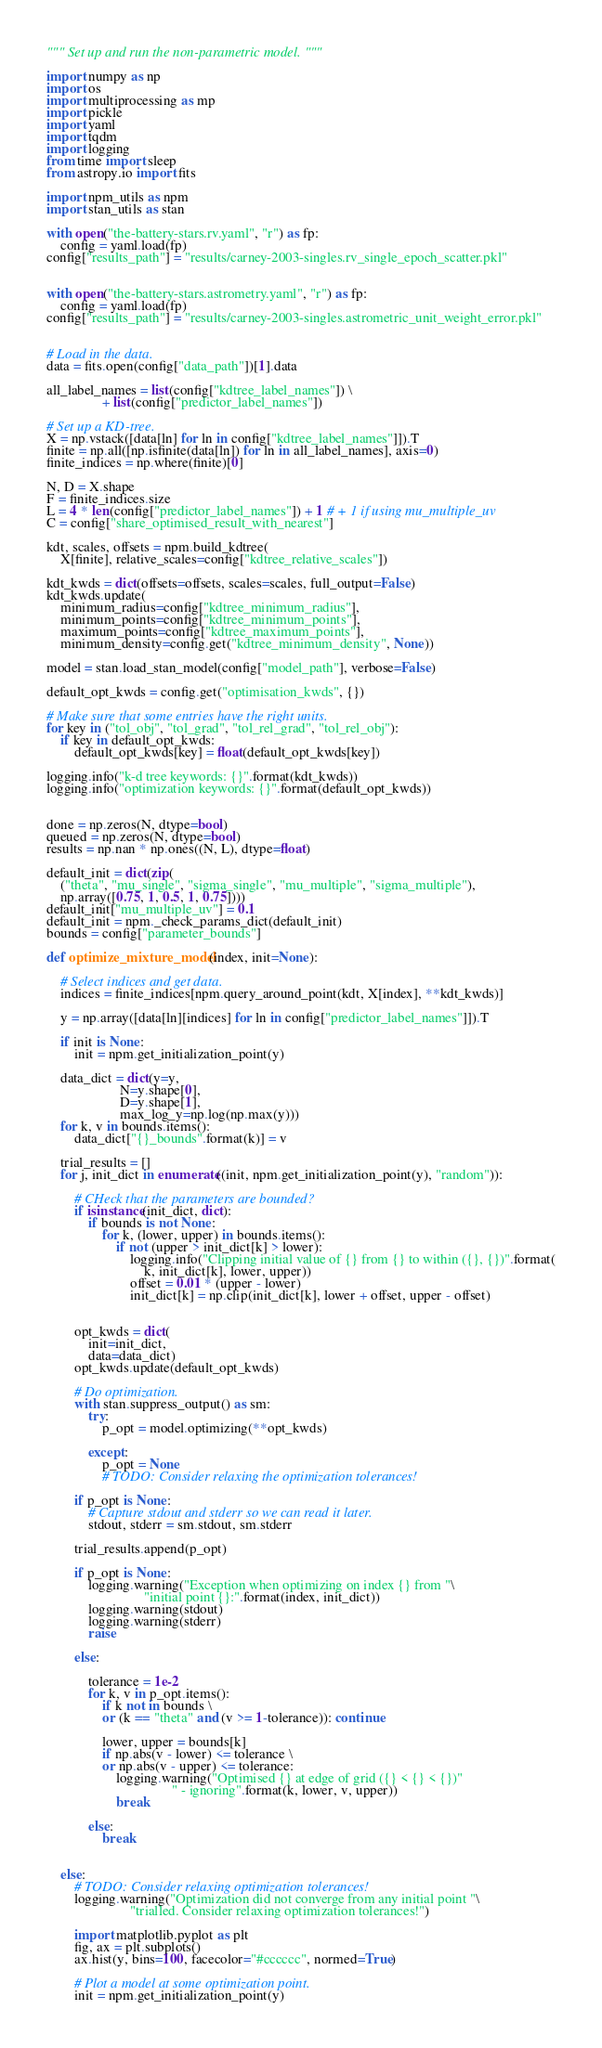<code> <loc_0><loc_0><loc_500><loc_500><_Python_>
""" Set up and run the non-parametric model. """

import numpy as np
import os
import multiprocessing as mp
import pickle
import yaml
import tqdm
import logging
from time import sleep
from astropy.io import fits

import npm_utils as npm
import stan_utils as stan

with open("the-battery-stars.rv.yaml", "r") as fp:
    config = yaml.load(fp)
config["results_path"] = "results/carney-2003-singles.rv_single_epoch_scatter.pkl"


with open("the-battery-stars.astrometry.yaml", "r") as fp:
    config = yaml.load(fp)
config["results_path"] = "results/carney-2003-singles.astrometric_unit_weight_error.pkl"


# Load in the data.
data = fits.open(config["data_path"])[1].data

all_label_names = list(config["kdtree_label_names"]) \
                + list(config["predictor_label_names"])

# Set up a KD-tree.
X = np.vstack([data[ln] for ln in config["kdtree_label_names"]]).T
finite = np.all([np.isfinite(data[ln]) for ln in all_label_names], axis=0)
finite_indices = np.where(finite)[0]

N, D = X.shape
F = finite_indices.size
L = 4 * len(config["predictor_label_names"]) + 1 # + 1 if using mu_multiple_uv
C = config["share_optimised_result_with_nearest"]

kdt, scales, offsets = npm.build_kdtree(
    X[finite], relative_scales=config["kdtree_relative_scales"])

kdt_kwds = dict(offsets=offsets, scales=scales, full_output=False)
kdt_kwds.update(
    minimum_radius=config["kdtree_minimum_radius"],
    minimum_points=config["kdtree_minimum_points"],
    maximum_points=config["kdtree_maximum_points"],
    minimum_density=config.get("kdtree_minimum_density", None))

model = stan.load_stan_model(config["model_path"], verbose=False)

default_opt_kwds = config.get("optimisation_kwds", {})

# Make sure that some entries have the right units.
for key in ("tol_obj", "tol_grad", "tol_rel_grad", "tol_rel_obj"):
    if key in default_opt_kwds:
        default_opt_kwds[key] = float(default_opt_kwds[key])

logging.info("k-d tree keywords: {}".format(kdt_kwds))
logging.info("optimization keywords: {}".format(default_opt_kwds))


done = np.zeros(N, dtype=bool)
queued = np.zeros(N, dtype=bool)
results = np.nan * np.ones((N, L), dtype=float)

default_init = dict(zip(
    ("theta", "mu_single", "sigma_single", "mu_multiple", "sigma_multiple"),
    np.array([0.75, 1, 0.5, 1, 0.75])))
default_init["mu_multiple_uv"] = 0.1
default_init = npm._check_params_dict(default_init)
bounds = config["parameter_bounds"]

def optimize_mixture_model(index, init=None):

    # Select indices and get data.
    indices = finite_indices[npm.query_around_point(kdt, X[index], **kdt_kwds)]

    y = np.array([data[ln][indices] for ln in config["predictor_label_names"]]).T

    if init is None:
        init = npm.get_initialization_point(y)

    data_dict = dict(y=y, 
                     N=y.shape[0], 
                     D=y.shape[1],
                     max_log_y=np.log(np.max(y)))
    for k, v in bounds.items():
        data_dict["{}_bounds".format(k)] = v
    
    trial_results = []
    for j, init_dict in enumerate((init, npm.get_initialization_point(y), "random")):

        # CHeck that the parameters are bounded?
        if isinstance(init_dict, dict):
            if bounds is not None:
                for k, (lower, upper) in bounds.items():
                    if not (upper > init_dict[k] > lower):
                        logging.info("Clipping initial value of {} from {} to within ({}, {})".format(
                            k, init_dict[k], lower, upper))
                        offset = 0.01 * (upper - lower)
                        init_dict[k] = np.clip(init_dict[k], lower + offset, upper - offset)


        opt_kwds = dict(
            init=init_dict, 
            data=data_dict)
        opt_kwds.update(default_opt_kwds)

        # Do optimization.
        with stan.suppress_output() as sm:
            try:
                p_opt = model.optimizing(**opt_kwds)

            except:
                p_opt = None
                # TODO: Consider relaxing the optimization tolerances!

        if p_opt is None:
            # Capture stdout and stderr so we can read it later.
            stdout, stderr = sm.stdout, sm.stderr

        trial_results.append(p_opt)

        if p_opt is None:
            logging.warning("Exception when optimizing on index {} from "\
                            "initial point {}:".format(index, init_dict))
            logging.warning(stdout)
            logging.warning(stderr)
            raise

        else:

            tolerance = 1e-2
            for k, v in p_opt.items():
                if k not in bounds \
                or (k == "theta" and (v >= 1-tolerance)): continue

                lower, upper = bounds[k]
                if np.abs(v - lower) <= tolerance \
                or np.abs(v - upper) <= tolerance:
                    logging.warning("Optimised {} at edge of grid ({} < {} < {})"
                                    " - ignoring".format(k, lower, v, upper))
                    break

            else:
                break


    else:
        # TODO: Consider relaxing optimization tolerances!
        logging.warning("Optimization did not converge from any initial point "\
                        "trialled. Consider relaxing optimization tolerances!")

        import matplotlib.pyplot as plt
        fig, ax = plt.subplots()
        ax.hist(y, bins=100, facecolor="#cccccc", normed=True)

        # Plot a model at some optimization point.
        init = npm.get_initialization_point(y)</code> 